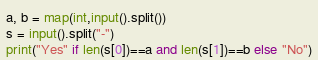Convert code to text. <code><loc_0><loc_0><loc_500><loc_500><_Python_>a, b = map(int,input().split())
s = input().split("-")
print("Yes" if len(s[0])==a and len(s[1])==b else "No")</code> 